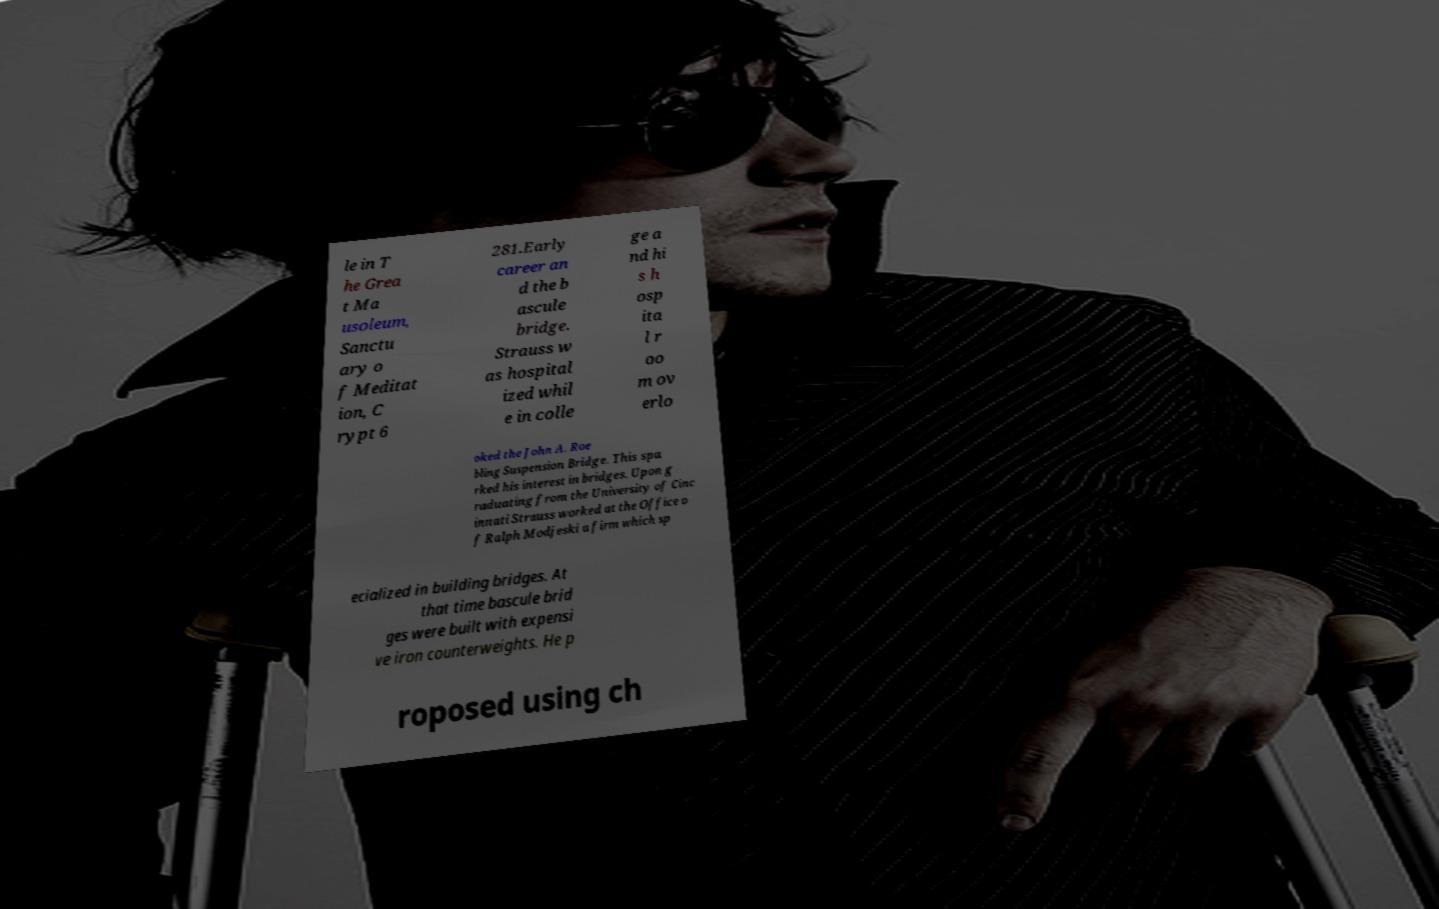Could you assist in decoding the text presented in this image and type it out clearly? le in T he Grea t Ma usoleum, Sanctu ary o f Meditat ion, C rypt 6 281.Early career an d the b ascule bridge. Strauss w as hospital ized whil e in colle ge a nd hi s h osp ita l r oo m ov erlo oked the John A. Roe bling Suspension Bridge. This spa rked his interest in bridges. Upon g raduating from the University of Cinc innati Strauss worked at the Office o f Ralph Modjeski a firm which sp ecialized in building bridges. At that time bascule brid ges were built with expensi ve iron counterweights. He p roposed using ch 